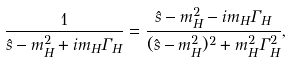<formula> <loc_0><loc_0><loc_500><loc_500>\frac { 1 } { \hat { s } - m _ { H } ^ { 2 } + i m _ { H } \Gamma _ { H } } = \frac { \hat { s } - m _ { H } ^ { 2 } - i m _ { H } \Gamma _ { H } } { ( \hat { s } - m _ { H } ^ { 2 } ) ^ { 2 } + m _ { H } ^ { 2 } \Gamma _ { H } ^ { 2 } } , \\</formula> 